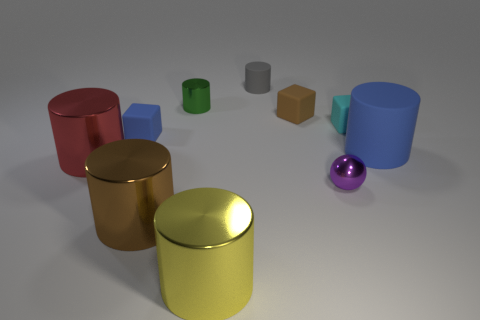Subtract all green cylinders. How many cylinders are left? 5 Subtract all brown rubber blocks. How many blocks are left? 2 Add 9 green cylinders. How many green cylinders exist? 10 Subtract 1 blue cubes. How many objects are left? 9 Subtract all cylinders. How many objects are left? 4 Subtract 4 cylinders. How many cylinders are left? 2 Subtract all yellow balls. Subtract all green blocks. How many balls are left? 1 Subtract all cyan cylinders. How many cyan balls are left? 0 Subtract all blue matte spheres. Subtract all tiny matte cylinders. How many objects are left? 9 Add 3 brown cubes. How many brown cubes are left? 4 